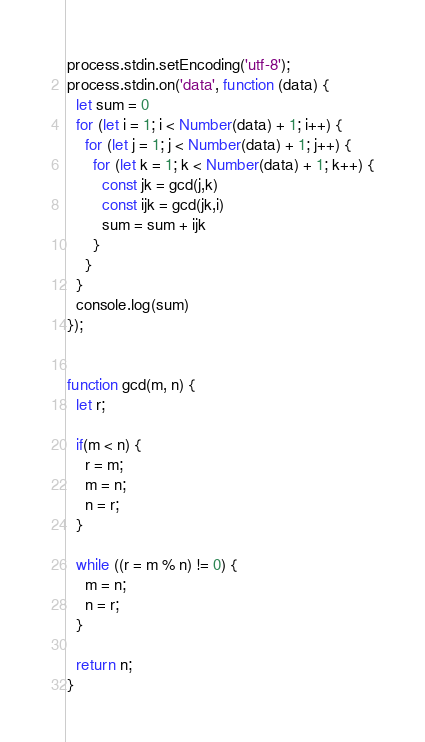<code> <loc_0><loc_0><loc_500><loc_500><_JavaScript_>process.stdin.setEncoding('utf-8');
process.stdin.on('data', function (data) {
  let sum = 0
  for (let i = 1; i < Number(data) + 1; i++) {
    for (let j = 1; j < Number(data) + 1; j++) {
      for (let k = 1; k < Number(data) + 1; k++) {
        const jk = gcd(j,k)
        const ijk = gcd(jk,i)
        sum = sum + ijk
      }
    }
  }
  console.log(sum)
});


function gcd(m, n) {
  let r;

  if(m < n) {  
    r = m;  
    m = n;
    n = r;
  }

  while ((r = m % n) != 0) {
    m = n;
    n = r;
  }

  return n;
}</code> 